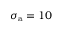Convert formula to latex. <formula><loc_0><loc_0><loc_500><loc_500>\sigma _ { a } = 1 0</formula> 